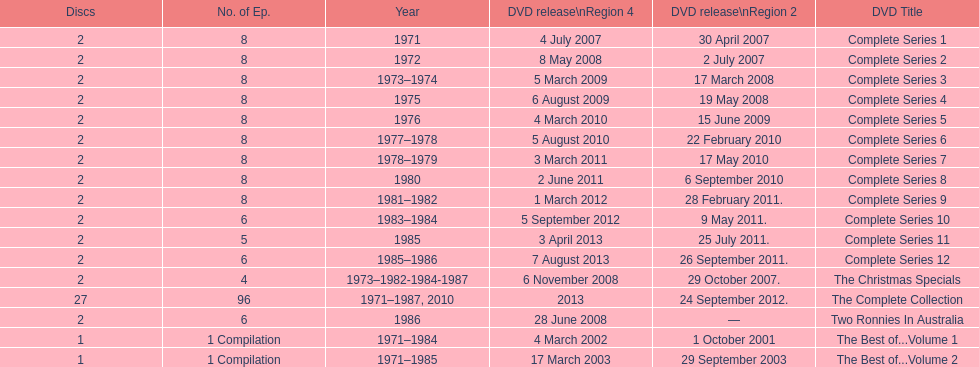Dvd shorter than 5 episodes The Christmas Specials. 